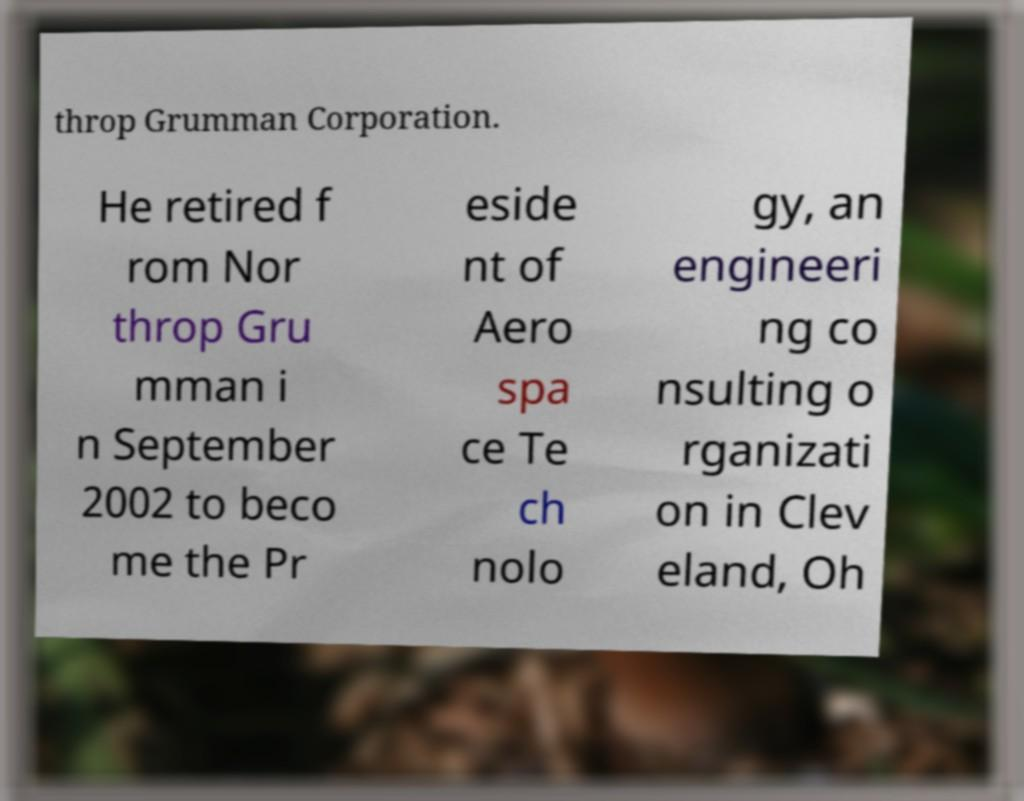Could you assist in decoding the text presented in this image and type it out clearly? throp Grumman Corporation. He retired f rom Nor throp Gru mman i n September 2002 to beco me the Pr eside nt of Aero spa ce Te ch nolo gy, an engineeri ng co nsulting o rganizati on in Clev eland, Oh 